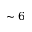<formula> <loc_0><loc_0><loc_500><loc_500>\sim 6</formula> 